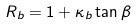Convert formula to latex. <formula><loc_0><loc_0><loc_500><loc_500>R _ { b } = 1 + \kappa _ { b } \tan \beta</formula> 